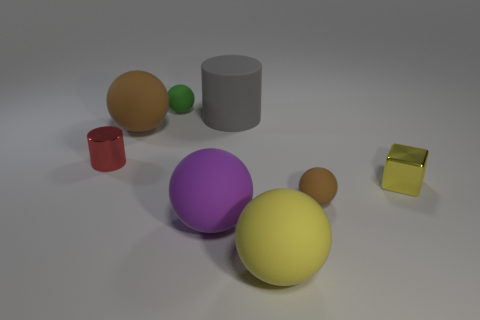Are there any green objects made of the same material as the large cylinder?
Your answer should be very brief. Yes. There is a tiny sphere that is left of the brown thing right of the big cylinder; is there a large gray rubber cylinder to the right of it?
Provide a short and direct response. Yes. What shape is the brown matte object that is the same size as the gray matte thing?
Give a very brief answer. Sphere. There is a red object behind the purple thing; is it the same size as the green matte sphere behind the small cube?
Your response must be concise. Yes. What number of shiny things are there?
Give a very brief answer. 2. What is the size of the cylinder that is on the right side of the tiny rubber ball that is on the left side of the tiny sphere that is in front of the red object?
Your answer should be very brief. Large. What number of large rubber objects are to the left of the red shiny object?
Give a very brief answer. 0. Are there an equal number of tiny brown balls that are on the left side of the purple rubber object and tiny cyan cylinders?
Provide a short and direct response. Yes. How many things are either big cyan matte spheres or cylinders?
Ensure brevity in your answer.  2. Is there any other thing that has the same shape as the tiny yellow thing?
Give a very brief answer. No. 